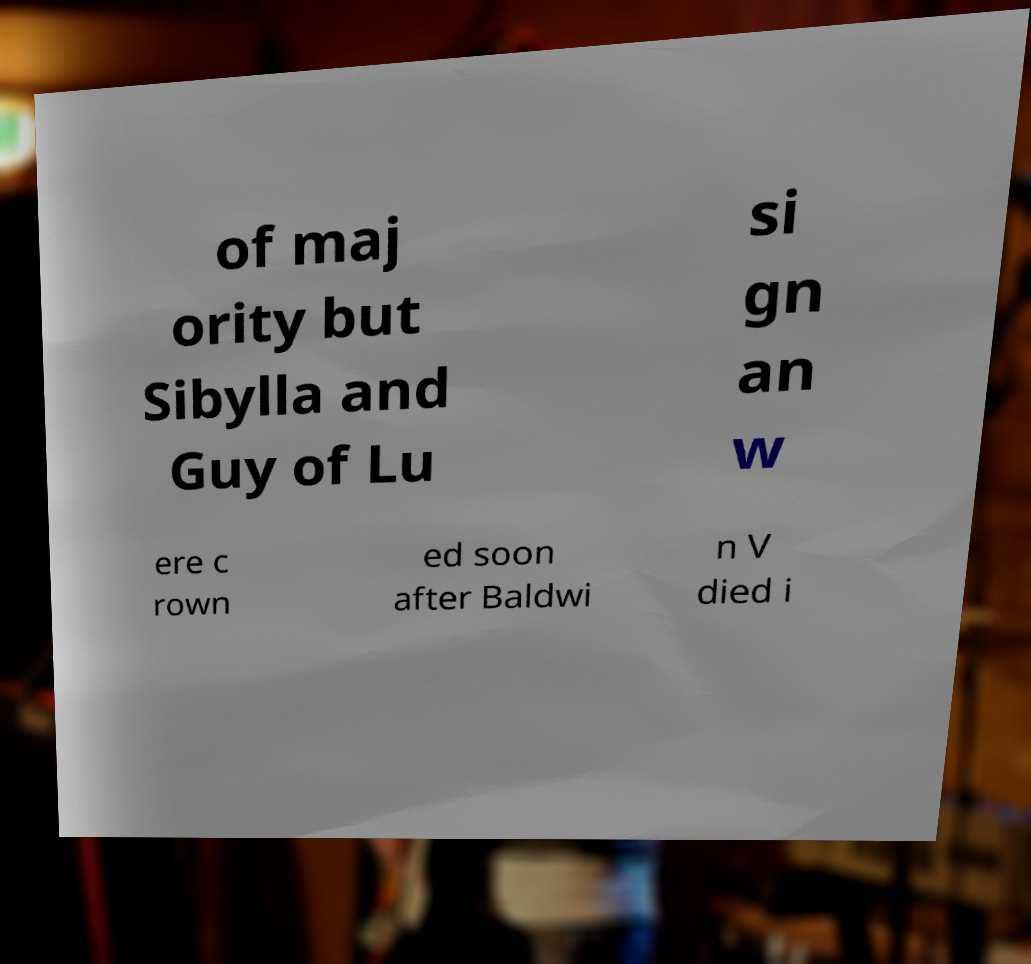Could you assist in decoding the text presented in this image and type it out clearly? of maj ority but Sibylla and Guy of Lu si gn an w ere c rown ed soon after Baldwi n V died i 